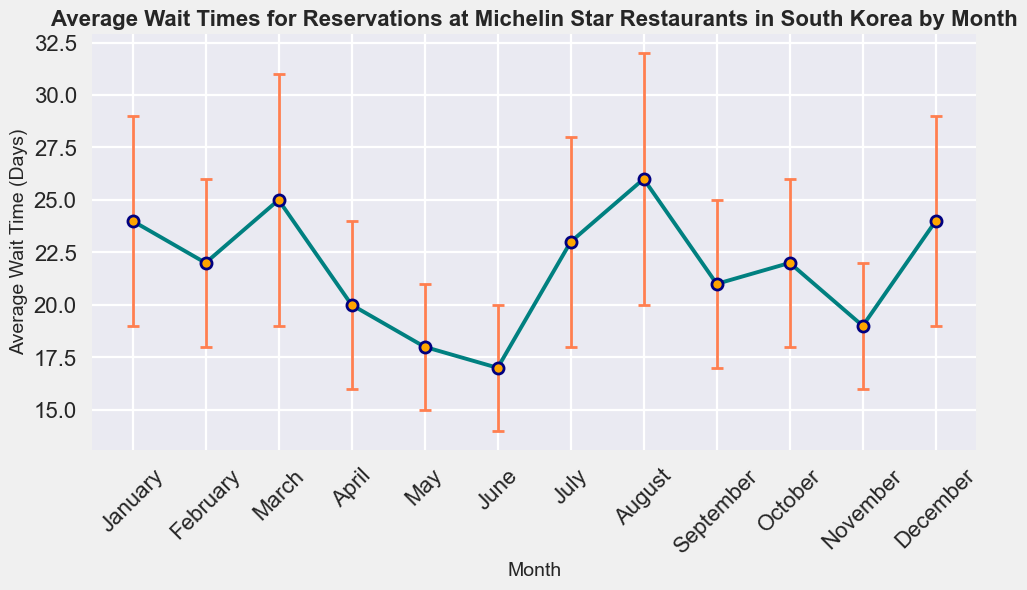What month has the highest average wait time for reservations? Observe the plot to find the month with the highest data point on the y-axis for average wait time.
Answer: August What is the difference in average wait time between January and June? Identify the average wait time for January (24 days) and June (17 days) from the plot, then subtract June's value from January's (24 - 17).
Answer: 7 days Which month shows the least variability in average wait time, and how can you tell? Examine the error bars in the plot; the month with the shortest error bar indicates the least variability.
Answer: May Compare the average wait times in July and November. Which month has a longer wait time? Look at the average wait time for July (23 days) and November (19 days) in the plot and compare their values.
Answer: July Calculate the overall average wait time across all months shown in the plot. Add all the average wait times (24+22+25+20+18+17+23+26+21+22+19+24) and divide by the number of months (12). ((24+22+25+20+18+17+23+26+21+22+19+24)/12)
Answer: 22.25 days In which month(s) does the average wait time fall within 20 and 23 days inclusive? Identify the average wait times that fall within the 20-23 days range. The months are April (20), September (21), October (22), and February (22).
Answer: April, September, October, February Between which months does the error margin remain consistent? Observe the plot for error bars with the same length. The error margin remains consistent in February and October (both 4 days).
Answer: February and October During which month is the difference between the upper bound and the average wait time the largest? Upper bound is calculated by adding the error margin to the average wait time. Calculate this for all months and identify the largest difference. August (26 + 6 = 32 days) has the largest difference.
Answer: August What is the range of average wait times shown in the plot? Subtract the smallest average wait time (June, 17 days) from the largest average wait time (August, 26 days).
Answer: 9 days How does the average wait time in May compare to December? Compare the average wait times for May (18 days) and December (24 days). May has a shorter wait time.
Answer: May is shorter 